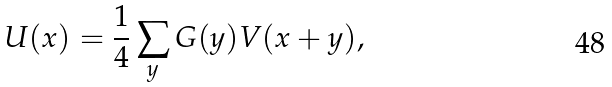<formula> <loc_0><loc_0><loc_500><loc_500>U ( x ) = \frac { 1 } { 4 } \sum _ { y } G ( y ) V ( x + y ) ,</formula> 